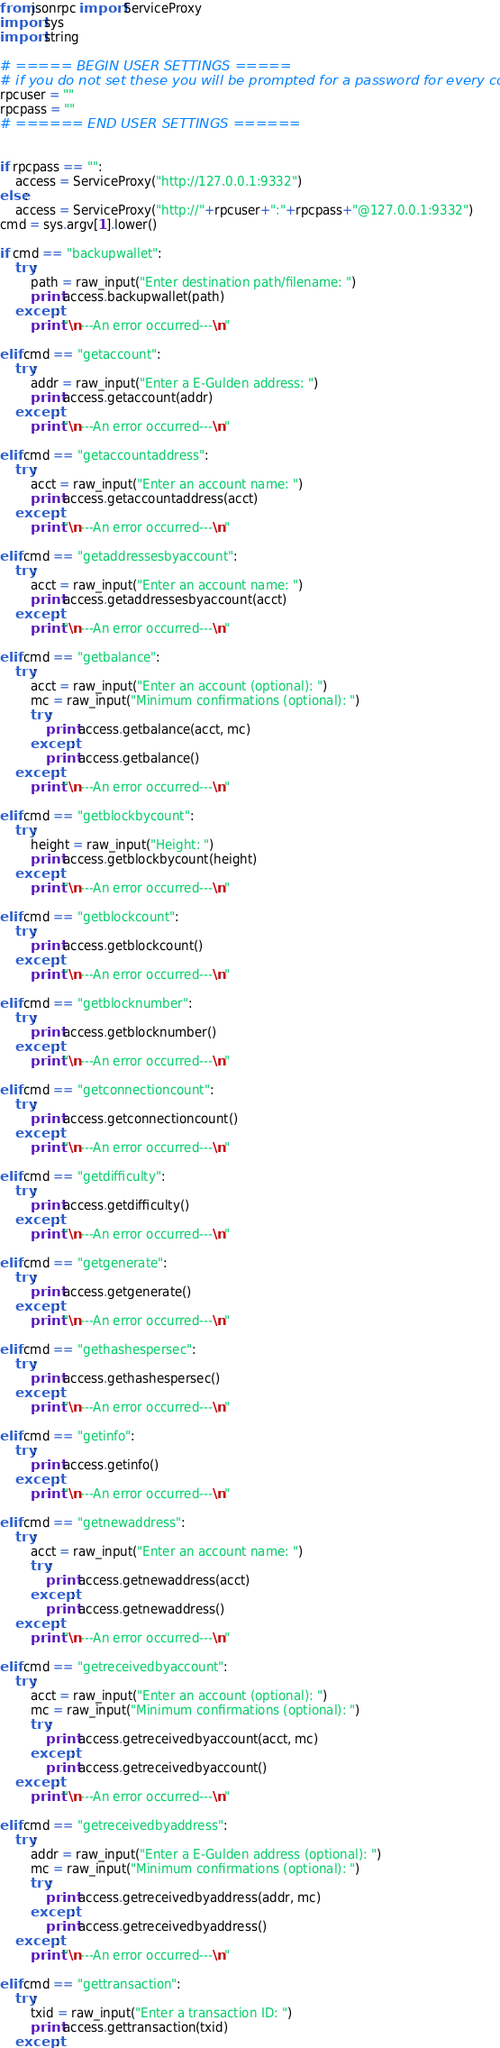Convert code to text. <code><loc_0><loc_0><loc_500><loc_500><_Python_>from jsonrpc import ServiceProxy
import sys
import string

# ===== BEGIN USER SETTINGS =====
# if you do not set these you will be prompted for a password for every command
rpcuser = ""
rpcpass = ""
# ====== END USER SETTINGS ======


if rpcpass == "":
	access = ServiceProxy("http://127.0.0.1:9332")
else:
	access = ServiceProxy("http://"+rpcuser+":"+rpcpass+"@127.0.0.1:9332")
cmd = sys.argv[1].lower()

if cmd == "backupwallet":
	try:
		path = raw_input("Enter destination path/filename: ")
		print access.backupwallet(path)
	except:
		print "\n---An error occurred---\n"

elif cmd == "getaccount":
	try:
		addr = raw_input("Enter a E-Gulden address: ")
		print access.getaccount(addr)
	except:
		print "\n---An error occurred---\n"

elif cmd == "getaccountaddress":
	try:
		acct = raw_input("Enter an account name: ")
		print access.getaccountaddress(acct)
	except:
		print "\n---An error occurred---\n"

elif cmd == "getaddressesbyaccount":
	try:
		acct = raw_input("Enter an account name: ")
		print access.getaddressesbyaccount(acct)
	except:
		print "\n---An error occurred---\n"

elif cmd == "getbalance":
	try:
		acct = raw_input("Enter an account (optional): ")
		mc = raw_input("Minimum confirmations (optional): ")
		try:
			print access.getbalance(acct, mc)
		except:
			print access.getbalance()
	except:
		print "\n---An error occurred---\n"

elif cmd == "getblockbycount":
	try:
		height = raw_input("Height: ")
		print access.getblockbycount(height)
	except:
		print "\n---An error occurred---\n"

elif cmd == "getblockcount":
	try:
		print access.getblockcount()
	except:
		print "\n---An error occurred---\n"

elif cmd == "getblocknumber":
	try:
		print access.getblocknumber()
	except:
		print "\n---An error occurred---\n"

elif cmd == "getconnectioncount":
	try:
		print access.getconnectioncount()
	except:
		print "\n---An error occurred---\n"

elif cmd == "getdifficulty":
	try:
		print access.getdifficulty()
	except:
		print "\n---An error occurred---\n"

elif cmd == "getgenerate":
	try:
		print access.getgenerate()
	except:
		print "\n---An error occurred---\n"

elif cmd == "gethashespersec":
	try:
		print access.gethashespersec()
	except:
		print "\n---An error occurred---\n"

elif cmd == "getinfo":
	try:
		print access.getinfo()
	except:
		print "\n---An error occurred---\n"

elif cmd == "getnewaddress":
	try:
		acct = raw_input("Enter an account name: ")
		try:
			print access.getnewaddress(acct)
		except:
			print access.getnewaddress()
	except:
		print "\n---An error occurred---\n"

elif cmd == "getreceivedbyaccount":
	try:
		acct = raw_input("Enter an account (optional): ")
		mc = raw_input("Minimum confirmations (optional): ")
		try:
			print access.getreceivedbyaccount(acct, mc)
		except:
			print access.getreceivedbyaccount()
	except:
		print "\n---An error occurred---\n"

elif cmd == "getreceivedbyaddress":
	try:
		addr = raw_input("Enter a E-Gulden address (optional): ")
		mc = raw_input("Minimum confirmations (optional): ")
		try:
			print access.getreceivedbyaddress(addr, mc)
		except:
			print access.getreceivedbyaddress()
	except:
		print "\n---An error occurred---\n"

elif cmd == "gettransaction":
	try:
		txid = raw_input("Enter a transaction ID: ")
		print access.gettransaction(txid)
	except:</code> 